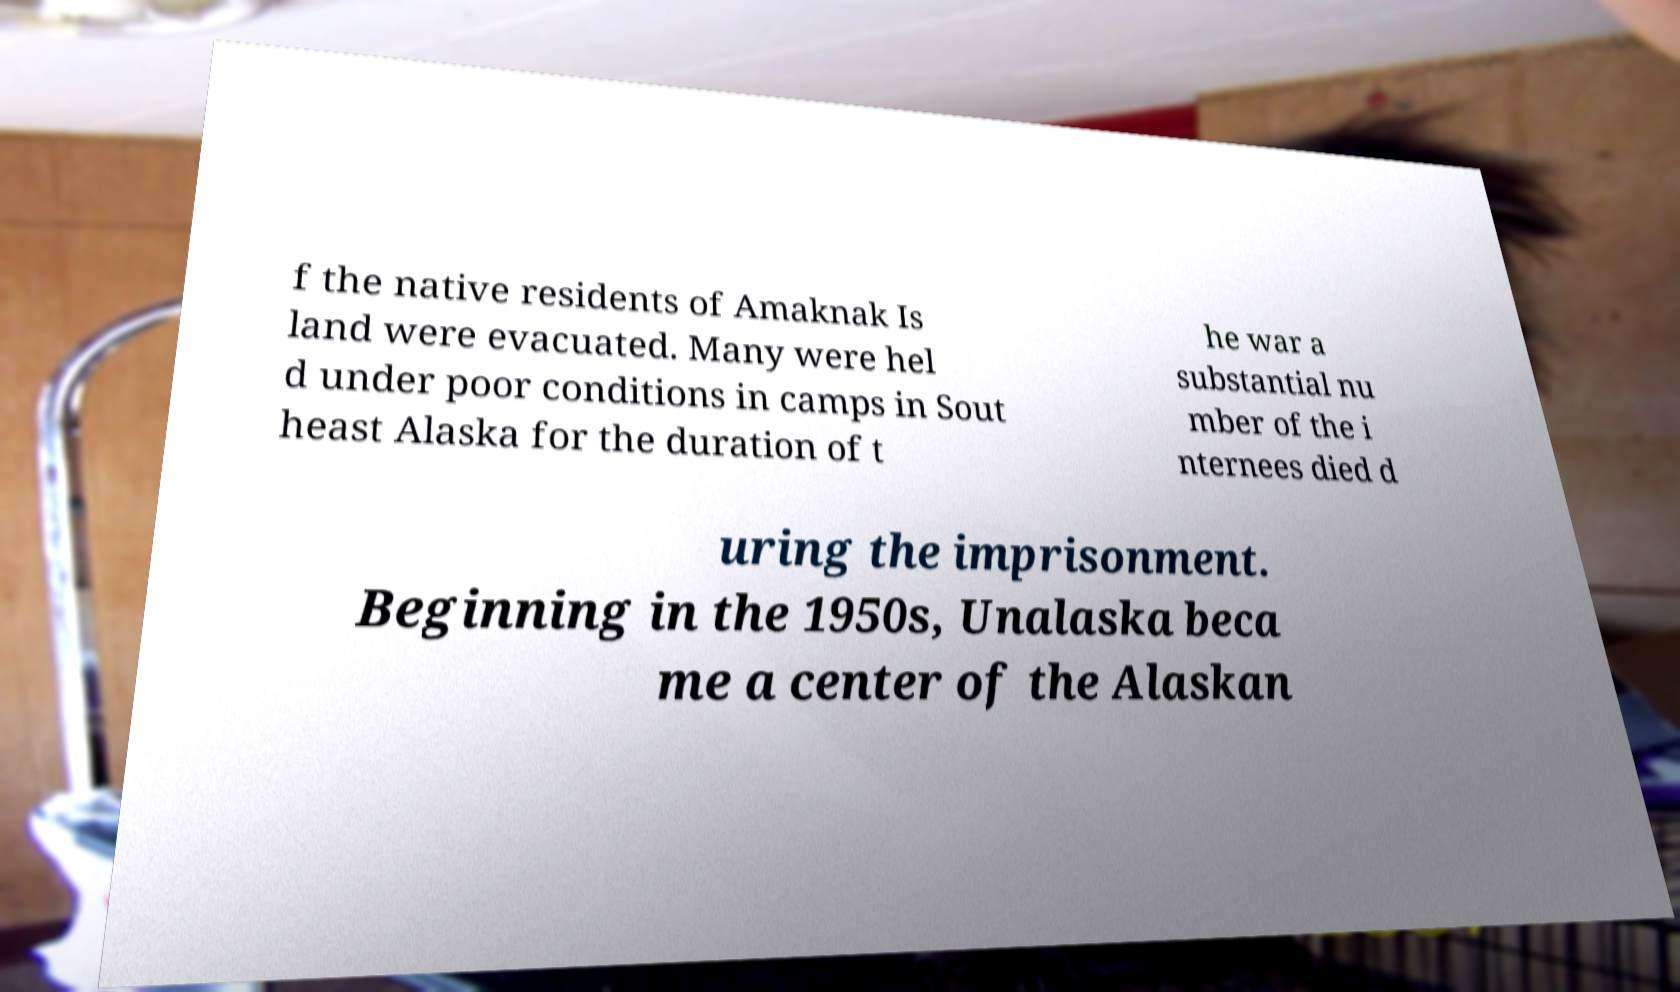For documentation purposes, I need the text within this image transcribed. Could you provide that? f the native residents of Amaknak Is land were evacuated. Many were hel d under poor conditions in camps in Sout heast Alaska for the duration of t he war a substantial nu mber of the i nternees died d uring the imprisonment. Beginning in the 1950s, Unalaska beca me a center of the Alaskan 